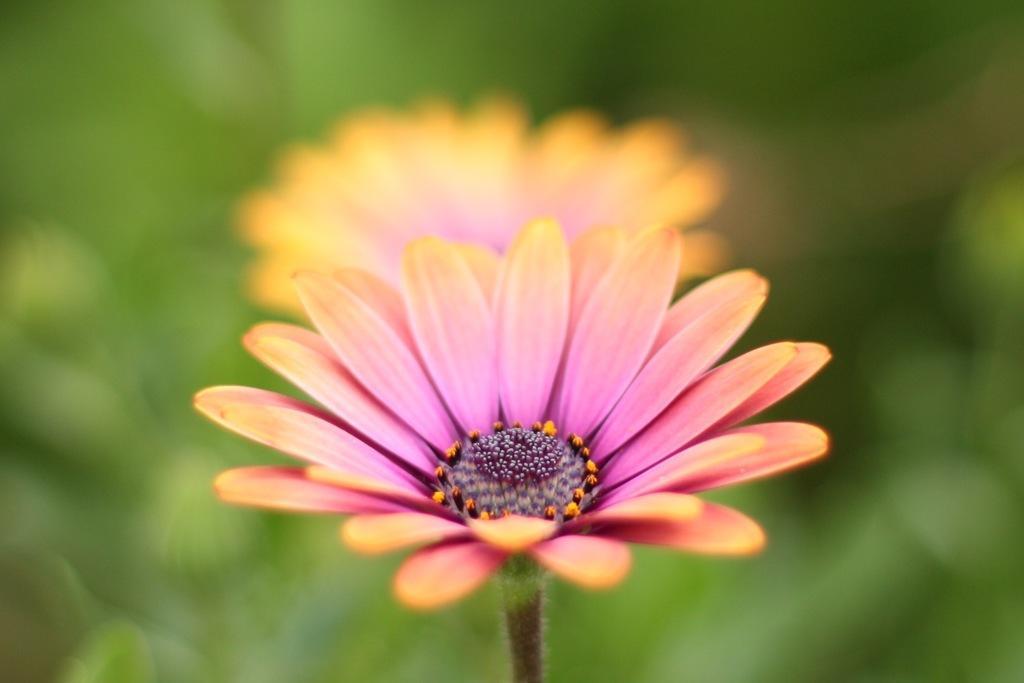Describe this image in one or two sentences. This picture shows couple of flowers. They are pink in color. 